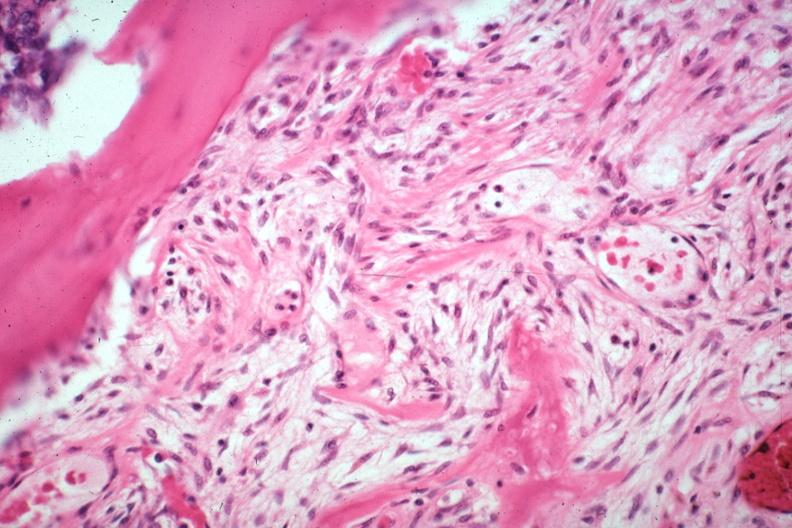what is present?
Answer the question using a single word or phrase. Joints 